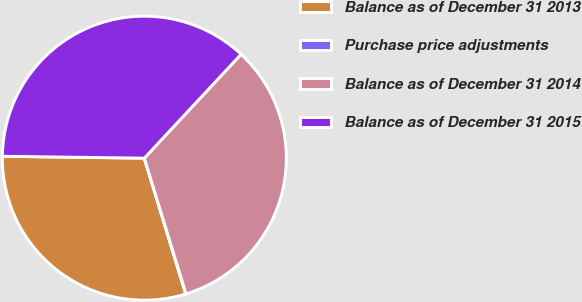<chart> <loc_0><loc_0><loc_500><loc_500><pie_chart><fcel>Balance as of December 31 2013<fcel>Purchase price adjustments<fcel>Balance as of December 31 2014<fcel>Balance as of December 31 2015<nl><fcel>29.92%<fcel>0.04%<fcel>33.32%<fcel>36.72%<nl></chart> 